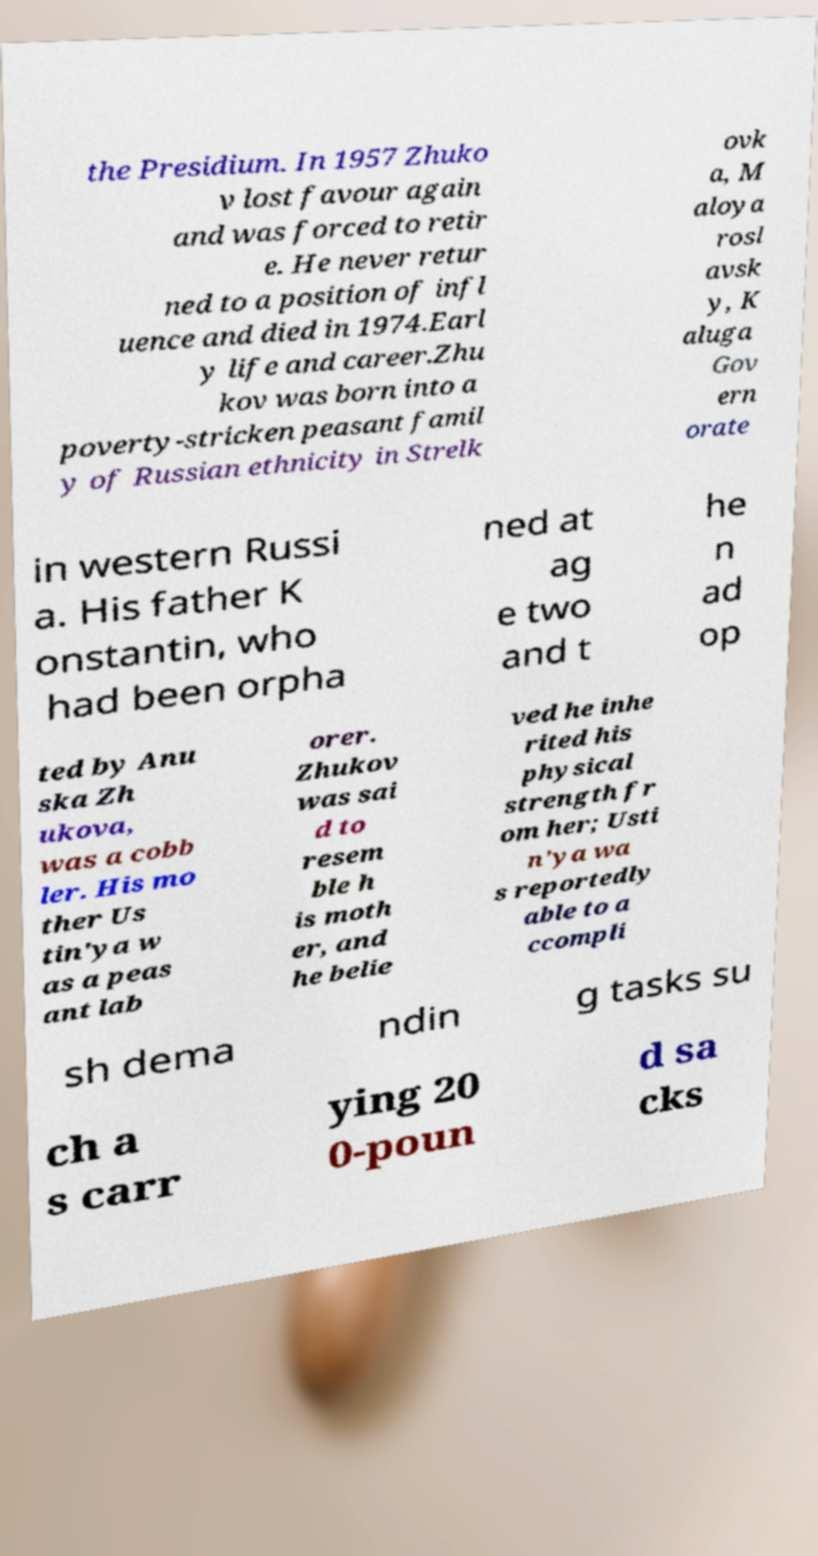Could you assist in decoding the text presented in this image and type it out clearly? the Presidium. In 1957 Zhuko v lost favour again and was forced to retir e. He never retur ned to a position of infl uence and died in 1974.Earl y life and career.Zhu kov was born into a poverty-stricken peasant famil y of Russian ethnicity in Strelk ovk a, M aloya rosl avsk y, K aluga Gov ern orate in western Russi a. His father K onstantin, who had been orpha ned at ag e two and t he n ad op ted by Anu ska Zh ukova, was a cobb ler. His mo ther Us tin'ya w as a peas ant lab orer. Zhukov was sai d to resem ble h is moth er, and he belie ved he inhe rited his physical strength fr om her; Usti n'ya wa s reportedly able to a ccompli sh dema ndin g tasks su ch a s carr ying 20 0-poun d sa cks 